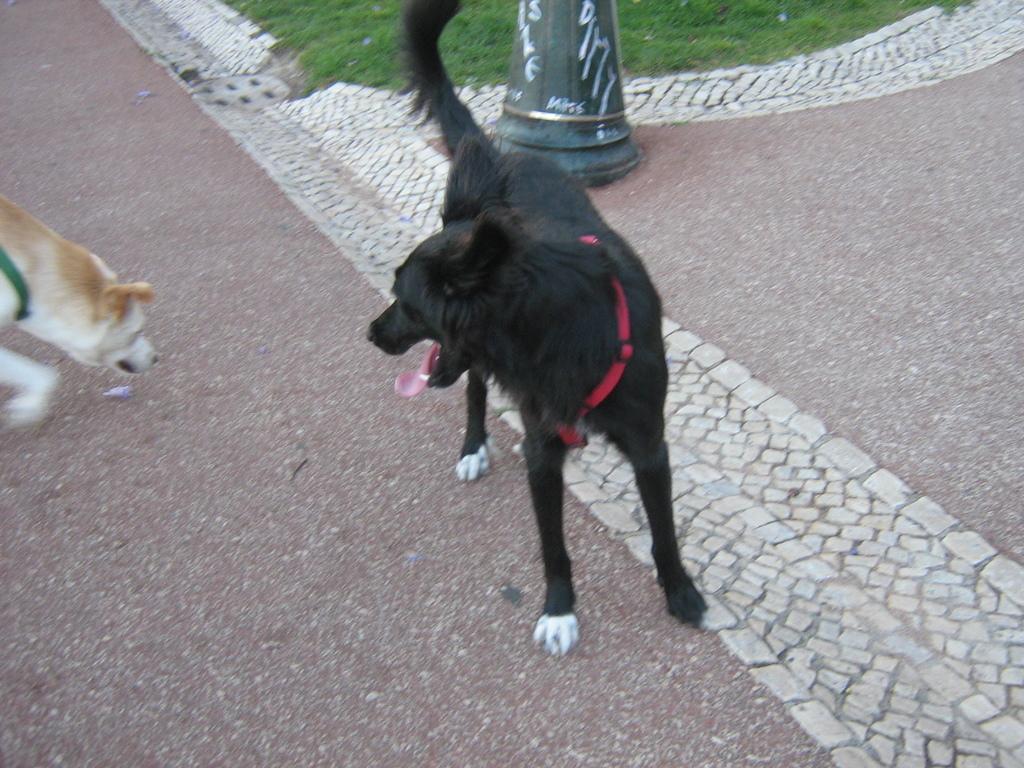Describe this image in one or two sentences. There is a black color dog in the center of the image and another dog on the left side, it seems like a pole and grassland at the top side. 